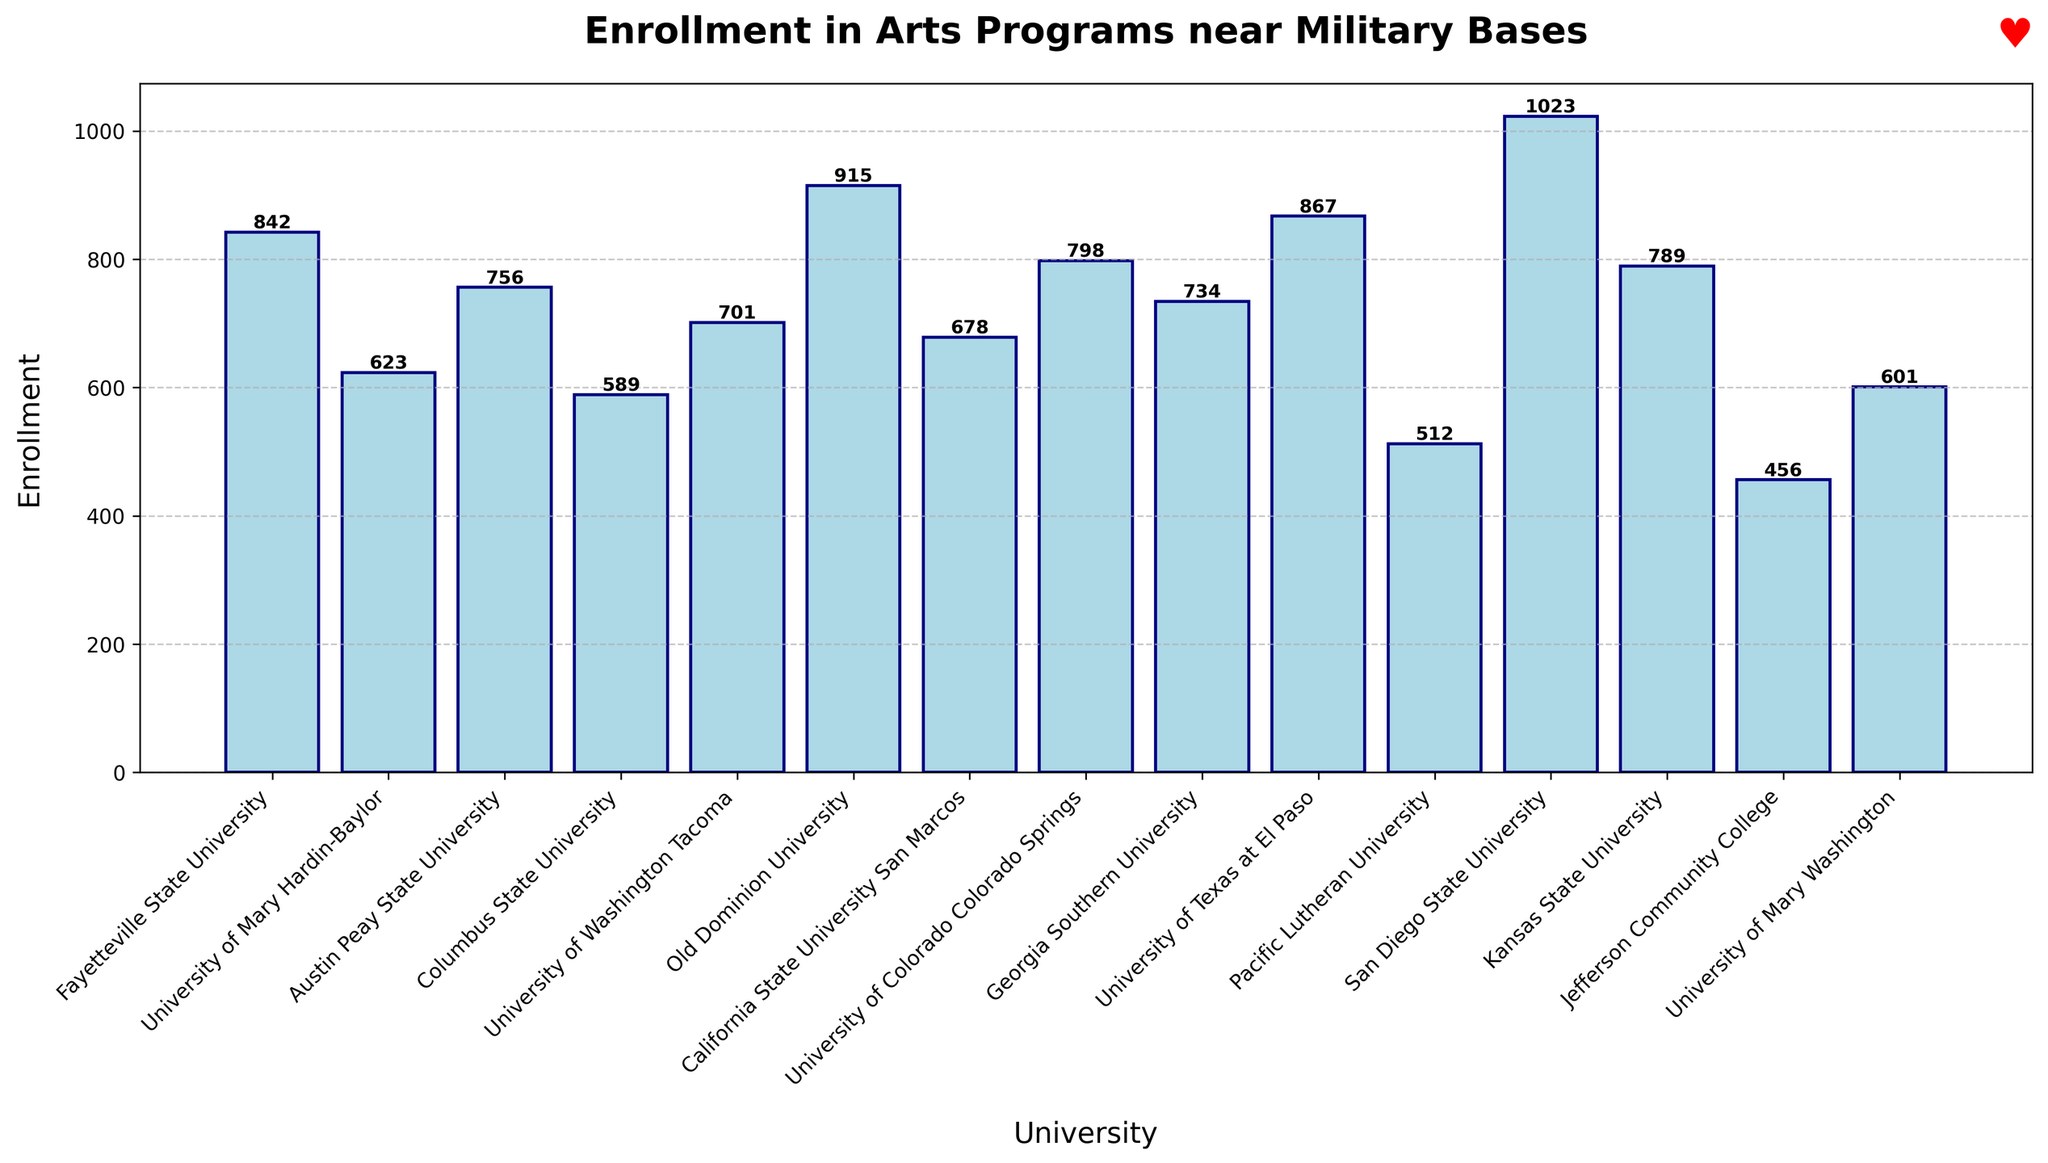What's the enrollment at the university near Naval Base San Diego? Naval Base San Diego is associated with San Diego State University, which is one of the bars on the chart. The height of this bar is labeled as 1023.
Answer: 1023 Which university has the lowest enrollment in arts programs? By observing the bar heights and labels, Jefferson Community College near Fort Drum has the shortest bar, with an enrollment of 456.
Answer: Jefferson Community College How much higher is the enrollment at Naval Station Norfolk compared to Fort Lewis? Naval Station Norfolk is linked to Old Dominion University with an enrollment of 915. Fort Lewis is linked to University of Washington Tacoma with an enrollment of 701. The difference is 915 - 701 = 214.
Answer: 214 Which university near which military base has slightly over 800 enrollments? By checking the labels, University of Colorado Colorado Springs near Fort Carson has an enrollment of 798, which is close to 800 but slightly less. No university has "slightly over" 800 enrollments. The closest match is University of Colorado Colorado Springs with 798.
Answer: University of Colorado Colorado Springs (798) List the universities with enrollments greater than 900. By identifying the bars with labels over 900, they are Naval Base San Diego (1023), Naval Station Norfolk (915), and Fort Bliss (867).
Answer: San Diego State University, Old Dominion University What is the total enrollment of the universities near Fort Bragg and Fort Hood? Fort Bragg's bar shows 842 enrollments and Fort Hood's bar shows 623 enrollments. Their combined total is 842 + 623 = 1465.
Answer: 1465 Is the enrollment at Fort Riley's associated university higher than the median enrollment of all universities? First, sort the enrollments to find the median. The sorted enrollments: 456, 512, 589, 601, 623, 678, 701, 734, 756, 789, 798, 842, 867, 915, 1023. The median (middle value) is the 8th value, which is 734. Fort Riley is linked to Kansas State University with an enrollment of 789, which is higher than the median of 734.
Answer: Yes, it is higher Which universities have enrollments between 700 and 800? Universities with enrollments between 700 and 800 are University of Washington Tacoma (701), Georgia Southern University (734), and Kansas State University (789).
Answer: University of Washington Tacoma, Georgia Southern University, Kansas State University 